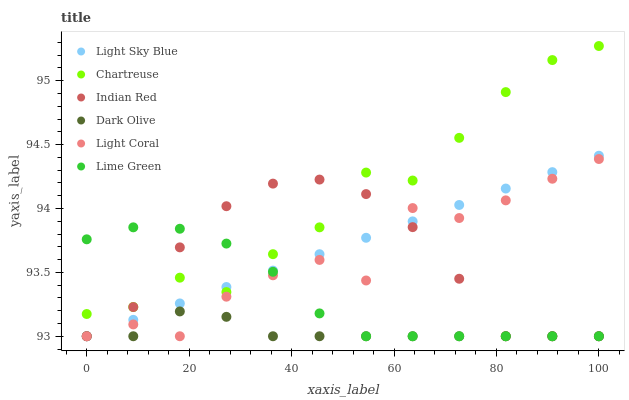Does Dark Olive have the minimum area under the curve?
Answer yes or no. Yes. Does Chartreuse have the maximum area under the curve?
Answer yes or no. Yes. Does Light Coral have the minimum area under the curve?
Answer yes or no. No. Does Light Coral have the maximum area under the curve?
Answer yes or no. No. Is Light Sky Blue the smoothest?
Answer yes or no. Yes. Is Light Coral the roughest?
Answer yes or no. Yes. Is Chartreuse the smoothest?
Answer yes or no. No. Is Chartreuse the roughest?
Answer yes or no. No. Does Dark Olive have the lowest value?
Answer yes or no. Yes. Does Chartreuse have the lowest value?
Answer yes or no. No. Does Chartreuse have the highest value?
Answer yes or no. Yes. Does Light Coral have the highest value?
Answer yes or no. No. Is Dark Olive less than Chartreuse?
Answer yes or no. Yes. Is Chartreuse greater than Light Coral?
Answer yes or no. Yes. Does Indian Red intersect Light Coral?
Answer yes or no. Yes. Is Indian Red less than Light Coral?
Answer yes or no. No. Is Indian Red greater than Light Coral?
Answer yes or no. No. Does Dark Olive intersect Chartreuse?
Answer yes or no. No. 